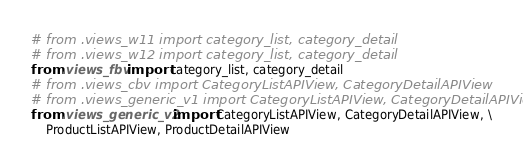<code> <loc_0><loc_0><loc_500><loc_500><_Python_># from .views_w11 import category_list, category_detail
# from .views_w12 import category_list, category_detail
from .views_fbv import category_list, category_detail
# from .views_cbv import CategoryListAPIView, CategoryDetailAPIView
# from .views_generic_v1 import CategoryListAPIView, CategoryDetailAPIView
from .views_generic_v2 import CategoryListAPIView, CategoryDetailAPIView, \
    ProductListAPIView, ProductDetailAPIView</code> 